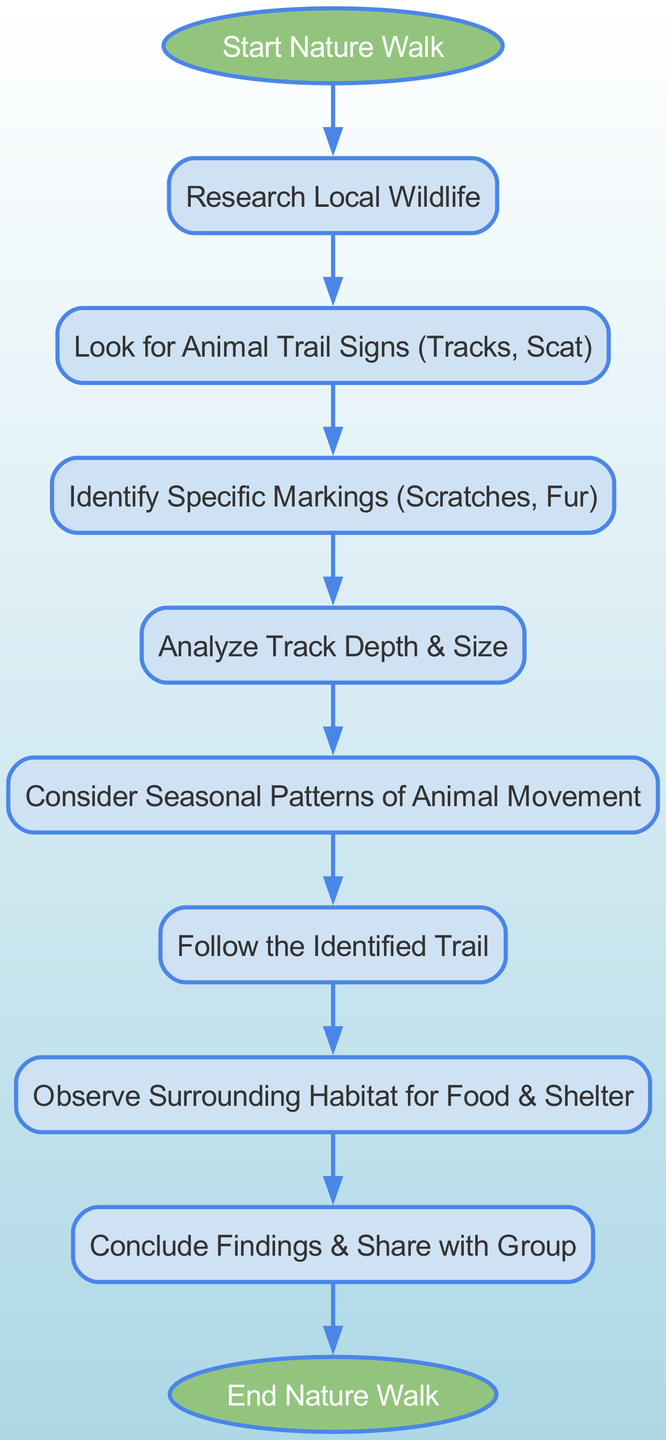What is the first step in the flow chart? The first step in the flow chart is represented by the "Start Nature Walk" node, which triggers the entire process. Therefore, the answer comes directly from the first element in the diagram.
Answer: Start Nature Walk How many nodes are there in the flow chart? By counting all the elements listed in the diagram, including the start and end nodes, we find there are ten nodes in total.
Answer: 10 What follows "Research Local Wildlife" in the flow chart? The diagram shows a direct connection from "Research Local Wildlife" to "Look for Animal Trail Signs (Tracks, Scat)", indicating this is the next step after research.
Answer: Look for Animal Trail Signs (Tracks, Scat) Which step involves analyzing track characteristics? "Analyze Track Depth & Size" is the designated node in the diagram that specifically addresses analyzing track characteristics when following the flow of the process.
Answer: Analyze Track Depth & Size What step comes before observing the habitat? According to the connections in the diagram, the step that precedes "Observe Surrounding Habitat for Food & Shelter" is "Follow the Identified Trail". This shows the logical sequence of steps involved.
Answer: Follow the Identified Trail How does "Consider Seasonal Patterns of Animal Movement" relate to the identification of trails? The diagram indicates that after analyzing track depth and size, one should "Consider Seasonal Patterns of Animal Movement", which adds valuable context to understand the animal movements and improve trail identification.
Answer: It helps improve trail identification What is the last step in the flow chart? The flow chart concludes with the "End Nature Walk" node, which signifies the completion of the entire process outlined in the preceding steps.
Answer: End Nature Walk Which nodes are connected by edges indicating a sequential relationship? The edges in the diagram show a sequential flow connecting each step in a linear fashion, with nodes such as "Look for Animal Trail Signs" leading directly to "Identify Specific Markings", forming a chain of related activities.
Answer: Each subsequent step follows from the previous one What is the purpose of identifying specific markings? The purpose of identifying specific markings like scratches or fur is reflected in the flow chart's structure, indicating it informs the analysis of habitats related to animal trails and enhances the understanding of wildlife presence.
Answer: To enhance understanding of wildlife presence 